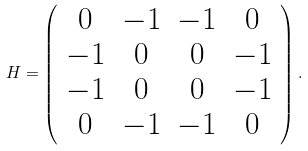<formula> <loc_0><loc_0><loc_500><loc_500>H = \left ( \begin{array} { c c c c } 0 & - 1 & - 1 & 0 \\ - 1 & 0 & 0 & - 1 \\ - 1 & 0 & 0 & - 1 \\ 0 & - 1 & - 1 & 0 \end{array} \right ) .</formula> 